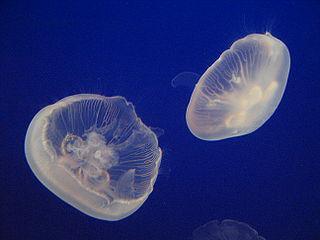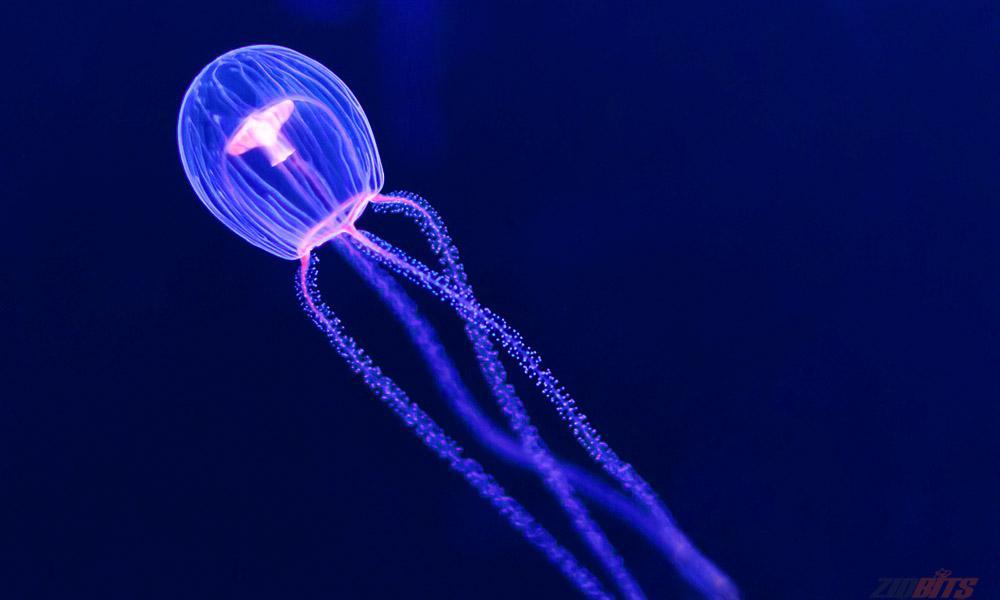The first image is the image on the left, the second image is the image on the right. Given the left and right images, does the statement "a jealyfish is pictured against a black background." hold true? Answer yes or no. No. 